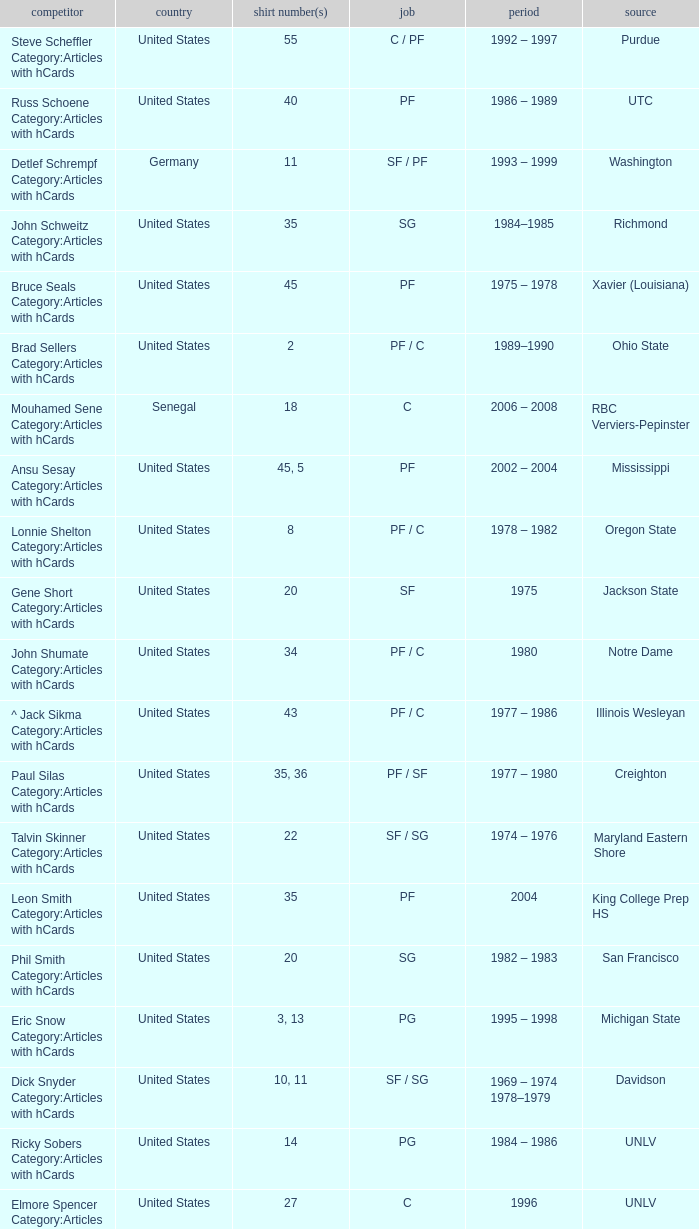What nationality is the player from Oregon State? United States. 